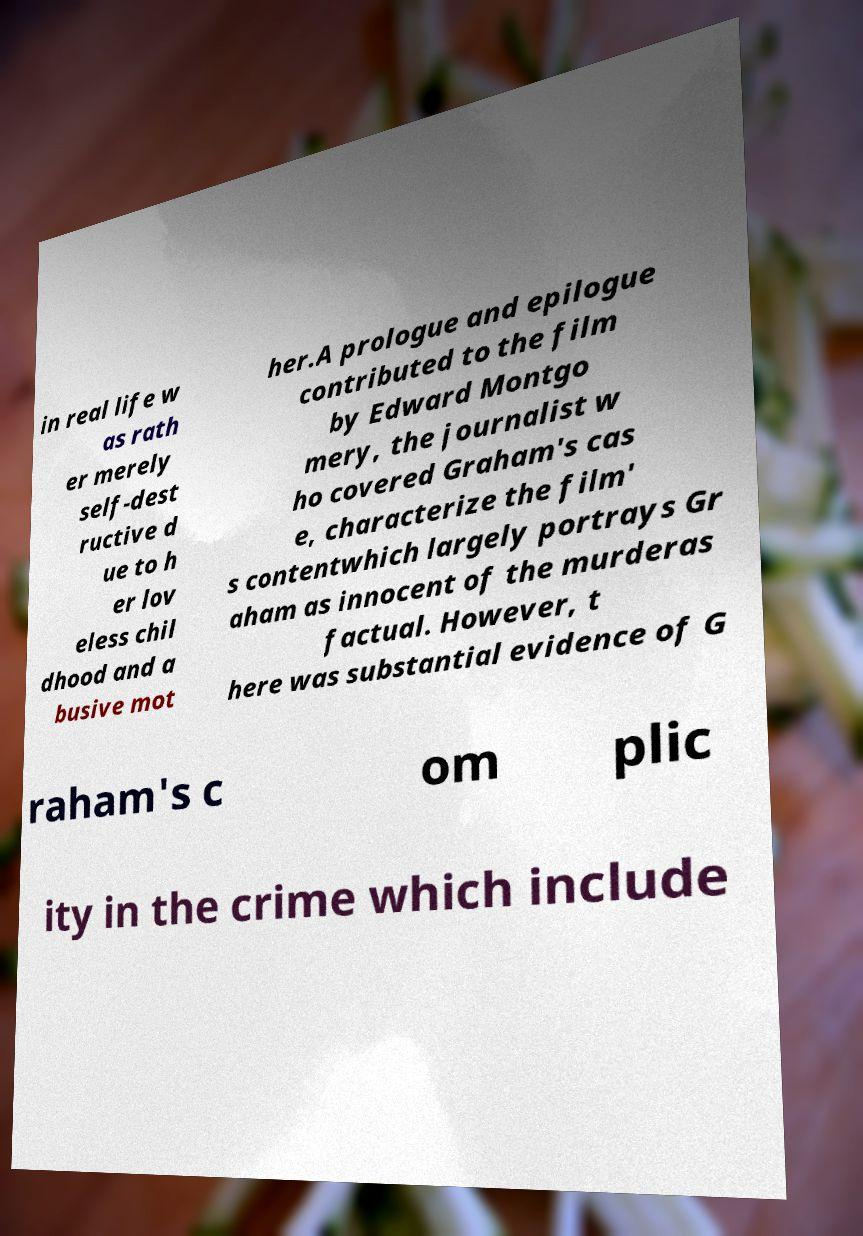Could you extract and type out the text from this image? in real life w as rath er merely self-dest ructive d ue to h er lov eless chil dhood and a busive mot her.A prologue and epilogue contributed to the film by Edward Montgo mery, the journalist w ho covered Graham's cas e, characterize the film' s contentwhich largely portrays Gr aham as innocent of the murderas factual. However, t here was substantial evidence of G raham's c om plic ity in the crime which include 